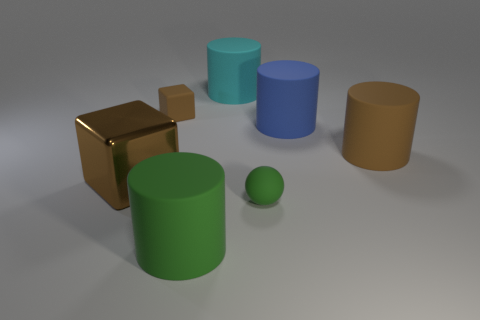Subtract all large green rubber cylinders. How many cylinders are left? 3 Subtract all green cylinders. How many cylinders are left? 3 Add 3 small blocks. How many objects exist? 10 Subtract 2 cylinders. How many cylinders are left? 2 Subtract all blocks. How many objects are left? 5 Subtract all green cylinders. Subtract all gray spheres. How many cylinders are left? 3 Subtract all metal objects. Subtract all large blocks. How many objects are left? 5 Add 5 cyan cylinders. How many cyan cylinders are left? 6 Add 3 big brown matte cylinders. How many big brown matte cylinders exist? 4 Subtract 0 gray spheres. How many objects are left? 7 